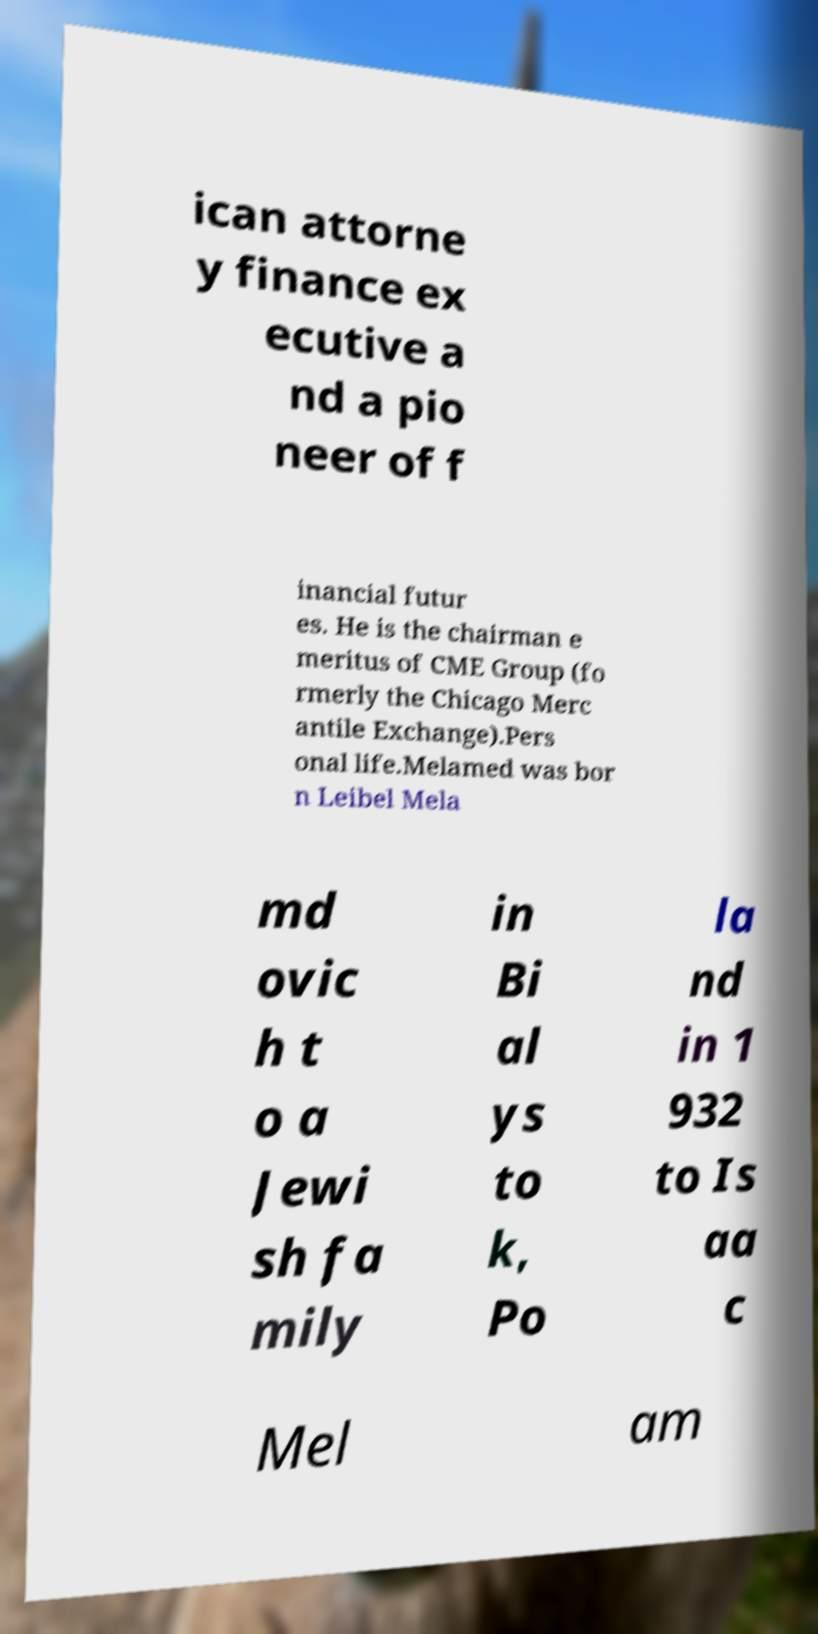Could you extract and type out the text from this image? ican attorne y finance ex ecutive a nd a pio neer of f inancial futur es. He is the chairman e meritus of CME Group (fo rmerly the Chicago Merc antile Exchange).Pers onal life.Melamed was bor n Leibel Mela md ovic h t o a Jewi sh fa mily in Bi al ys to k, Po la nd in 1 932 to Is aa c Mel am 